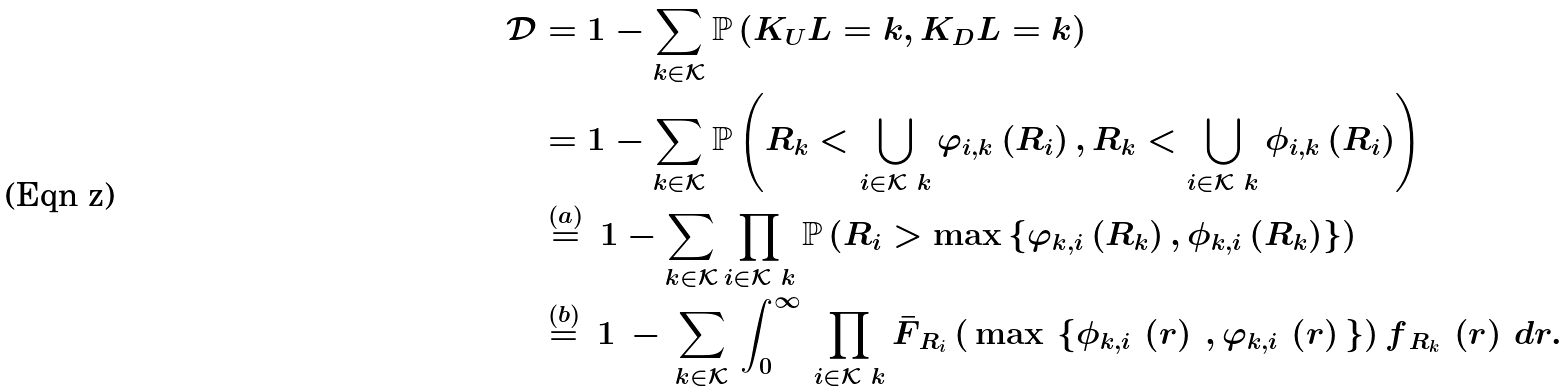<formula> <loc_0><loc_0><loc_500><loc_500>\mathcal { D } & = 1 - \sum _ { k \in \mathcal { K } } \mathbb { P } \left ( K _ { U } L = k , K _ { D } L = k \right ) \\ & = 1 - \sum _ { k \in \mathcal { K } } \mathbb { P } \left ( R _ { k } < \bigcup _ { i \in \mathcal { K } \ k } \varphi _ { i , k } \left ( R _ { i } \right ) , R _ { k } < \bigcup _ { i \in \mathcal { K } \ k } \phi _ { i , k } \left ( R _ { i } \right ) \right ) \\ & \overset { ( a ) } { = } \, 1 - \sum _ { k \in \mathcal { K } } \prod _ { i \in \mathcal { K } \ k } \mathbb { P } \left ( R _ { i } > \max \left \{ \varphi _ { k , i } \left ( R _ { k } \right ) , \phi _ { k , i } \left ( R _ { k } \right ) \right \} \right ) \\ & \overset { ( b ) } { = } \, 1 \, - \, \sum _ { k \in \mathcal { K } } \, \int _ { 0 } ^ { \infty } \, \prod _ { i \in \mathcal { K } \ k } \bar { F } _ { \, R _ { i } } \left ( \, \max \, \left \{ \phi _ { k , i } \, \left ( r \right ) \, , \varphi _ { k , i } \, \left ( r \right ) \, \right \} \right ) f _ { \, R _ { k } } \, \left ( r \right ) \, d r .</formula> 